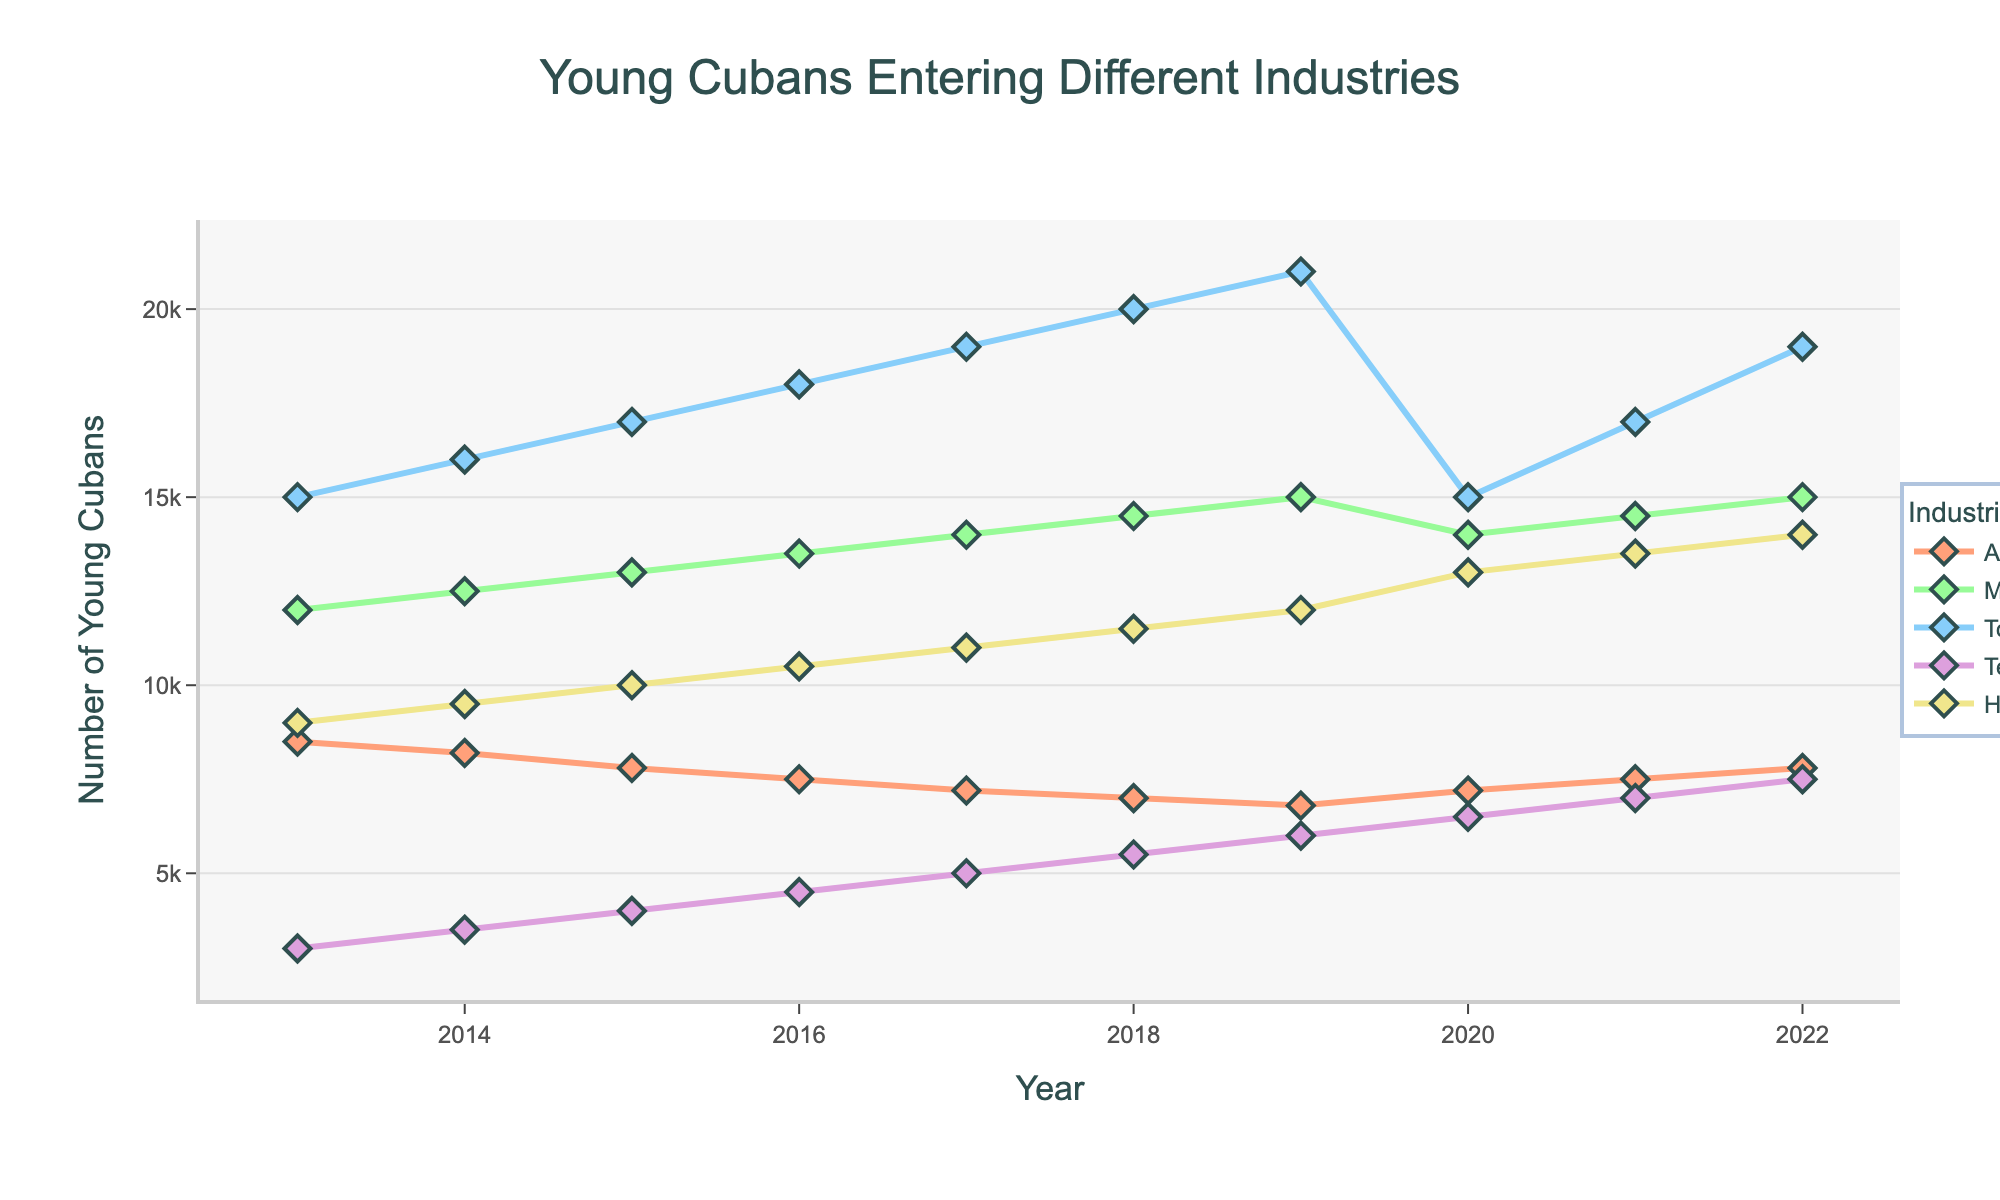Which industry had the highest number of young Cubans entering it in 2022? From the figure, look at the values for different industries in 2022. Technology had the highest growth, rising to around 7500, but it was the tourism industry that had the highest number with 19000 young Cubans.
Answer: Tourism What was the trend in the number of young Cubans entering Agricultural professions between 2013 and 2019? From the figure, visually analyze the line for Agriculture between 2013 and 2019. The number consistently decreased from 8500 in 2013 to 6800 in 2019.
Answer: Decreasing How did the number of young Cubans entering the Manufacturing industry change from 2019 to 2020? Identify the value for Manufacturing in 2019 and compare it to the value in 2020. It declined from 15000 in 2019 to 14000 in 2020.
Answer: Decrease Which two industries have the most similar trends between 2020 and 2022? Compare the lines for each industry visually for the years 2020, 2021, and 2022. Both Manufacturing and Agriculture show a similar recovery trend in these years.
Answer: Manufacturing and Agriculture On average, how many young Cubans entered the Technology industry each year from 2014 to 2017? Sum the values for Technology from 2014 to 2017 and then divide by the number of years. (3500 + 4000 + 4500 + 5000) / 4 = 4250
Answer: 4250 Which year saw the greatest increase in the number of young Cubans entering the Healthcare sector? Look at the line for Healthcare and identify the year-to-year increments. The largest jump occurred from 2019 to 2020, increasing from 12000 to 13000.
Answer: 2020 By how much did the number of young Cubans in the Tourism industry increase from 2013 to 2019? Subtract the value in 2013 from the value in 2019 for Tourism. 21000 - 15000 = 6000
Answer: 6000 Compare the number of young Cubans entering the Agricultural and Technology sectors in 2021. Which sector had more, and by how much? Find the values for both industries in 2021. Agriculture had 7500 and Technology had 7000. Agriculture had 500 more than Technology.
Answer: Agriculture by 500 Was there any industry where the number of young Cubans increased every year from 2013 to 2022? Visually inspect each industry's line graph to check for consistent yearly increases. Tourism consistently increased every year.
Answer: Tourism What's the total number of young Cubans entering the Manufacturing industry from 2013 to 2022? Sum the values for Manufacturing for each year from 2013 to 2022: 12000 + 12500 + 13000 + 13500 + 14000 + 14500 + 15000 + 14000 + 14500 + 15000 = 128000
Answer: 128000 